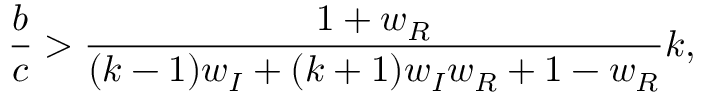<formula> <loc_0><loc_0><loc_500><loc_500>\frac { b } { c } > \frac { 1 + w _ { R } } { ( k - 1 ) w _ { I } + ( k + 1 ) w _ { I } w _ { R } + 1 - w _ { R } } k ,</formula> 